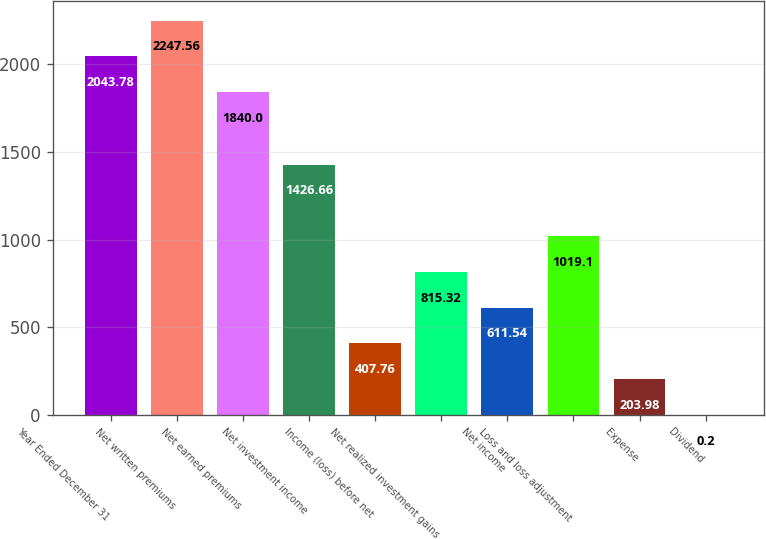Convert chart to OTSL. <chart><loc_0><loc_0><loc_500><loc_500><bar_chart><fcel>Year Ended December 31<fcel>Net written premiums<fcel>Net earned premiums<fcel>Net investment income<fcel>Income (loss) before net<fcel>Net realized investment gains<fcel>Net income<fcel>Loss and loss adjustment<fcel>Expense<fcel>Dividend<nl><fcel>2043.78<fcel>2247.56<fcel>1840<fcel>1426.66<fcel>407.76<fcel>815.32<fcel>611.54<fcel>1019.1<fcel>203.98<fcel>0.2<nl></chart> 